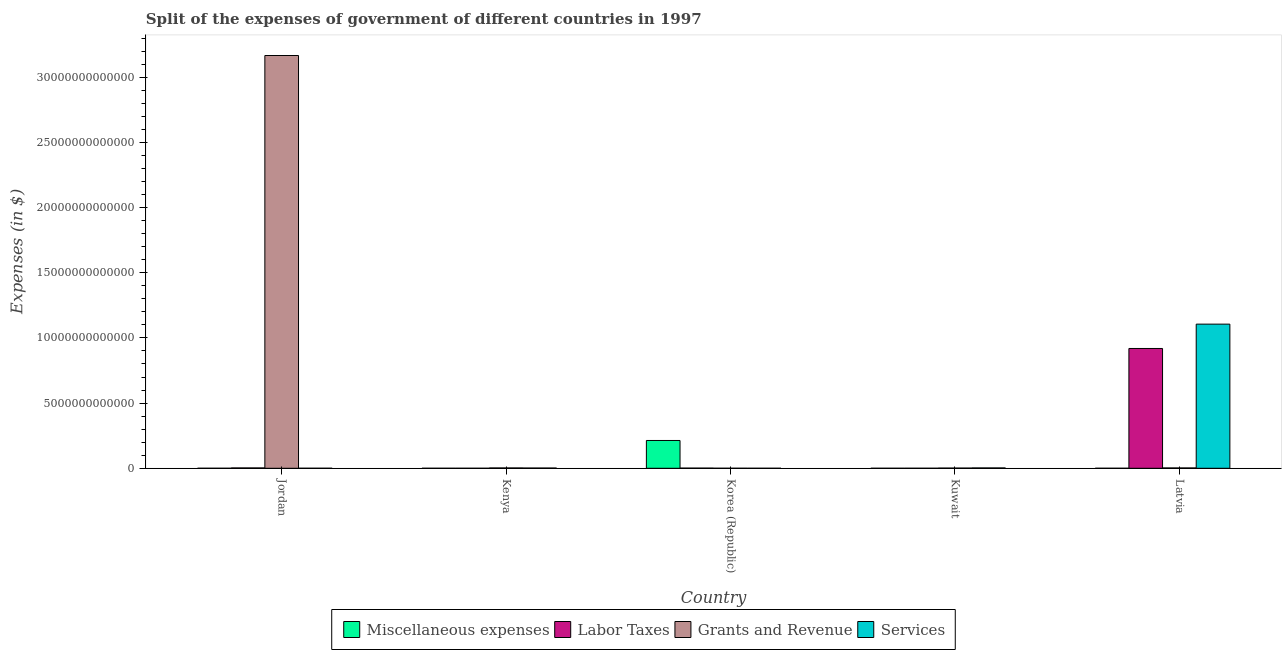How many different coloured bars are there?
Offer a very short reply. 4. How many groups of bars are there?
Your response must be concise. 5. Are the number of bars per tick equal to the number of legend labels?
Keep it short and to the point. Yes. Are the number of bars on each tick of the X-axis equal?
Your answer should be compact. Yes. What is the label of the 1st group of bars from the left?
Offer a terse response. Jordan. In how many cases, is the number of bars for a given country not equal to the number of legend labels?
Make the answer very short. 0. What is the amount spent on miscellaneous expenses in Kenya?
Offer a terse response. 2.31e+08. Across all countries, what is the maximum amount spent on miscellaneous expenses?
Keep it short and to the point. 2.13e+12. Across all countries, what is the minimum amount spent on miscellaneous expenses?
Provide a succinct answer. 2.09e+07. In which country was the amount spent on grants and revenue maximum?
Offer a very short reply. Jordan. In which country was the amount spent on labor taxes minimum?
Make the answer very short. Kenya. What is the total amount spent on grants and revenue in the graph?
Your answer should be compact. 3.17e+13. What is the difference between the amount spent on grants and revenue in Kenya and that in Korea (Republic)?
Your answer should be very brief. 2.38e+1. What is the difference between the amount spent on services in Jordan and the amount spent on miscellaneous expenses in Korea (Republic)?
Ensure brevity in your answer.  -2.13e+12. What is the average amount spent on services per country?
Provide a succinct answer. 2.22e+12. What is the difference between the amount spent on grants and revenue and amount spent on labor taxes in Korea (Republic)?
Provide a succinct answer. -1.10e+1. What is the ratio of the amount spent on miscellaneous expenses in Korea (Republic) to that in Kuwait?
Your response must be concise. 9647.06. Is the difference between the amount spent on labor taxes in Korea (Republic) and Kuwait greater than the difference between the amount spent on services in Korea (Republic) and Kuwait?
Provide a short and direct response. Yes. What is the difference between the highest and the second highest amount spent on labor taxes?
Make the answer very short. 9.16e+12. What is the difference between the highest and the lowest amount spent on services?
Ensure brevity in your answer.  1.11e+13. Is the sum of the amount spent on services in Jordan and Kenya greater than the maximum amount spent on grants and revenue across all countries?
Provide a succinct answer. No. What does the 1st bar from the left in Korea (Republic) represents?
Your answer should be compact. Miscellaneous expenses. What does the 3rd bar from the right in Kuwait represents?
Make the answer very short. Labor Taxes. Is it the case that in every country, the sum of the amount spent on miscellaneous expenses and amount spent on labor taxes is greater than the amount spent on grants and revenue?
Make the answer very short. No. How many bars are there?
Give a very brief answer. 20. Are all the bars in the graph horizontal?
Provide a short and direct response. No. How many countries are there in the graph?
Your answer should be compact. 5. What is the difference between two consecutive major ticks on the Y-axis?
Provide a short and direct response. 5.00e+12. Does the graph contain any zero values?
Your answer should be very brief. No. Does the graph contain grids?
Your answer should be compact. No. What is the title of the graph?
Your response must be concise. Split of the expenses of government of different countries in 1997. What is the label or title of the X-axis?
Give a very brief answer. Country. What is the label or title of the Y-axis?
Provide a succinct answer. Expenses (in $). What is the Expenses (in $) in Miscellaneous expenses in Jordan?
Your answer should be compact. 6.10e+07. What is the Expenses (in $) in Labor Taxes in Jordan?
Your answer should be compact. 2.58e+1. What is the Expenses (in $) in Grants and Revenue in Jordan?
Offer a terse response. 3.17e+13. What is the Expenses (in $) in Services in Jordan?
Give a very brief answer. 1.45e+09. What is the Expenses (in $) of Miscellaneous expenses in Kenya?
Offer a terse response. 2.31e+08. What is the Expenses (in $) in Labor Taxes in Kenya?
Ensure brevity in your answer.  1.24e+08. What is the Expenses (in $) of Grants and Revenue in Kenya?
Provide a short and direct response. 2.43e+1. What is the Expenses (in $) in Services in Kenya?
Ensure brevity in your answer.  1.71e+1. What is the Expenses (in $) of Miscellaneous expenses in Korea (Republic)?
Make the answer very short. 2.13e+12. What is the Expenses (in $) of Labor Taxes in Korea (Republic)?
Give a very brief answer. 1.15e+1. What is the Expenses (in $) of Grants and Revenue in Korea (Republic)?
Offer a very short reply. 5.38e+08. What is the Expenses (in $) of Services in Korea (Republic)?
Your answer should be very brief. 8.06e+07. What is the Expenses (in $) of Miscellaneous expenses in Kuwait?
Provide a short and direct response. 2.21e+08. What is the Expenses (in $) of Labor Taxes in Kuwait?
Make the answer very short. 1.22e+09. What is the Expenses (in $) of Grants and Revenue in Kuwait?
Your answer should be compact. 1.39e+1. What is the Expenses (in $) in Services in Kuwait?
Your answer should be very brief. 2.55e+1. What is the Expenses (in $) of Miscellaneous expenses in Latvia?
Your answer should be very brief. 2.09e+07. What is the Expenses (in $) in Labor Taxes in Latvia?
Offer a terse response. 9.19e+12. What is the Expenses (in $) of Grants and Revenue in Latvia?
Your answer should be very brief. 2.46e+1. What is the Expenses (in $) in Services in Latvia?
Your answer should be very brief. 1.11e+13. Across all countries, what is the maximum Expenses (in $) of Miscellaneous expenses?
Offer a very short reply. 2.13e+12. Across all countries, what is the maximum Expenses (in $) in Labor Taxes?
Your response must be concise. 9.19e+12. Across all countries, what is the maximum Expenses (in $) of Grants and Revenue?
Provide a succinct answer. 3.17e+13. Across all countries, what is the maximum Expenses (in $) in Services?
Your answer should be very brief. 1.11e+13. Across all countries, what is the minimum Expenses (in $) of Miscellaneous expenses?
Provide a short and direct response. 2.09e+07. Across all countries, what is the minimum Expenses (in $) of Labor Taxes?
Your response must be concise. 1.24e+08. Across all countries, what is the minimum Expenses (in $) in Grants and Revenue?
Your answer should be very brief. 5.38e+08. Across all countries, what is the minimum Expenses (in $) in Services?
Give a very brief answer. 8.06e+07. What is the total Expenses (in $) in Miscellaneous expenses in the graph?
Provide a succinct answer. 2.13e+12. What is the total Expenses (in $) in Labor Taxes in the graph?
Your response must be concise. 9.23e+12. What is the total Expenses (in $) of Grants and Revenue in the graph?
Offer a terse response. 3.17e+13. What is the total Expenses (in $) of Services in the graph?
Your answer should be very brief. 1.11e+13. What is the difference between the Expenses (in $) of Miscellaneous expenses in Jordan and that in Kenya?
Your answer should be compact. -1.70e+08. What is the difference between the Expenses (in $) of Labor Taxes in Jordan and that in Kenya?
Provide a short and direct response. 2.56e+1. What is the difference between the Expenses (in $) of Grants and Revenue in Jordan and that in Kenya?
Ensure brevity in your answer.  3.16e+13. What is the difference between the Expenses (in $) of Services in Jordan and that in Kenya?
Your response must be concise. -1.56e+1. What is the difference between the Expenses (in $) of Miscellaneous expenses in Jordan and that in Korea (Republic)?
Your response must be concise. -2.13e+12. What is the difference between the Expenses (in $) in Labor Taxes in Jordan and that in Korea (Republic)?
Your answer should be very brief. 1.42e+1. What is the difference between the Expenses (in $) of Grants and Revenue in Jordan and that in Korea (Republic)?
Your answer should be compact. 3.17e+13. What is the difference between the Expenses (in $) in Services in Jordan and that in Korea (Republic)?
Offer a very short reply. 1.37e+09. What is the difference between the Expenses (in $) of Miscellaneous expenses in Jordan and that in Kuwait?
Ensure brevity in your answer.  -1.60e+08. What is the difference between the Expenses (in $) in Labor Taxes in Jordan and that in Kuwait?
Provide a short and direct response. 2.45e+1. What is the difference between the Expenses (in $) in Grants and Revenue in Jordan and that in Kuwait?
Give a very brief answer. 3.16e+13. What is the difference between the Expenses (in $) in Services in Jordan and that in Kuwait?
Offer a very short reply. -2.41e+1. What is the difference between the Expenses (in $) of Miscellaneous expenses in Jordan and that in Latvia?
Your response must be concise. 4.01e+07. What is the difference between the Expenses (in $) of Labor Taxes in Jordan and that in Latvia?
Provide a succinct answer. -9.16e+12. What is the difference between the Expenses (in $) in Grants and Revenue in Jordan and that in Latvia?
Keep it short and to the point. 3.16e+13. What is the difference between the Expenses (in $) in Services in Jordan and that in Latvia?
Your answer should be compact. -1.11e+13. What is the difference between the Expenses (in $) of Miscellaneous expenses in Kenya and that in Korea (Republic)?
Make the answer very short. -2.13e+12. What is the difference between the Expenses (in $) in Labor Taxes in Kenya and that in Korea (Republic)?
Give a very brief answer. -1.14e+1. What is the difference between the Expenses (in $) of Grants and Revenue in Kenya and that in Korea (Republic)?
Provide a succinct answer. 2.38e+1. What is the difference between the Expenses (in $) in Services in Kenya and that in Korea (Republic)?
Your answer should be very brief. 1.70e+1. What is the difference between the Expenses (in $) in Labor Taxes in Kenya and that in Kuwait?
Offer a very short reply. -1.09e+09. What is the difference between the Expenses (in $) in Grants and Revenue in Kenya and that in Kuwait?
Make the answer very short. 1.04e+1. What is the difference between the Expenses (in $) of Services in Kenya and that in Kuwait?
Make the answer very short. -8.45e+09. What is the difference between the Expenses (in $) of Miscellaneous expenses in Kenya and that in Latvia?
Offer a terse response. 2.10e+08. What is the difference between the Expenses (in $) of Labor Taxes in Kenya and that in Latvia?
Offer a terse response. -9.19e+12. What is the difference between the Expenses (in $) in Grants and Revenue in Kenya and that in Latvia?
Give a very brief answer. -3.43e+08. What is the difference between the Expenses (in $) in Services in Kenya and that in Latvia?
Give a very brief answer. -1.10e+13. What is the difference between the Expenses (in $) of Miscellaneous expenses in Korea (Republic) and that in Kuwait?
Provide a succinct answer. 2.13e+12. What is the difference between the Expenses (in $) of Labor Taxes in Korea (Republic) and that in Kuwait?
Your answer should be very brief. 1.03e+1. What is the difference between the Expenses (in $) in Grants and Revenue in Korea (Republic) and that in Kuwait?
Ensure brevity in your answer.  -1.34e+1. What is the difference between the Expenses (in $) in Services in Korea (Republic) and that in Kuwait?
Offer a terse response. -2.55e+1. What is the difference between the Expenses (in $) in Miscellaneous expenses in Korea (Republic) and that in Latvia?
Provide a short and direct response. 2.13e+12. What is the difference between the Expenses (in $) of Labor Taxes in Korea (Republic) and that in Latvia?
Provide a succinct answer. -9.18e+12. What is the difference between the Expenses (in $) in Grants and Revenue in Korea (Republic) and that in Latvia?
Provide a succinct answer. -2.41e+1. What is the difference between the Expenses (in $) of Services in Korea (Republic) and that in Latvia?
Your response must be concise. -1.11e+13. What is the difference between the Expenses (in $) of Miscellaneous expenses in Kuwait and that in Latvia?
Provide a succinct answer. 2.00e+08. What is the difference between the Expenses (in $) of Labor Taxes in Kuwait and that in Latvia?
Your answer should be compact. -9.19e+12. What is the difference between the Expenses (in $) of Grants and Revenue in Kuwait and that in Latvia?
Provide a succinct answer. -1.07e+1. What is the difference between the Expenses (in $) in Services in Kuwait and that in Latvia?
Your response must be concise. -1.10e+13. What is the difference between the Expenses (in $) in Miscellaneous expenses in Jordan and the Expenses (in $) in Labor Taxes in Kenya?
Your response must be concise. -6.30e+07. What is the difference between the Expenses (in $) of Miscellaneous expenses in Jordan and the Expenses (in $) of Grants and Revenue in Kenya?
Your answer should be compact. -2.42e+1. What is the difference between the Expenses (in $) of Miscellaneous expenses in Jordan and the Expenses (in $) of Services in Kenya?
Your answer should be compact. -1.70e+1. What is the difference between the Expenses (in $) of Labor Taxes in Jordan and the Expenses (in $) of Grants and Revenue in Kenya?
Keep it short and to the point. 1.46e+09. What is the difference between the Expenses (in $) of Labor Taxes in Jordan and the Expenses (in $) of Services in Kenya?
Provide a short and direct response. 8.66e+09. What is the difference between the Expenses (in $) in Grants and Revenue in Jordan and the Expenses (in $) in Services in Kenya?
Give a very brief answer. 3.16e+13. What is the difference between the Expenses (in $) in Miscellaneous expenses in Jordan and the Expenses (in $) in Labor Taxes in Korea (Republic)?
Ensure brevity in your answer.  -1.15e+1. What is the difference between the Expenses (in $) of Miscellaneous expenses in Jordan and the Expenses (in $) of Grants and Revenue in Korea (Republic)?
Offer a terse response. -4.77e+08. What is the difference between the Expenses (in $) in Miscellaneous expenses in Jordan and the Expenses (in $) in Services in Korea (Republic)?
Offer a terse response. -1.97e+07. What is the difference between the Expenses (in $) in Labor Taxes in Jordan and the Expenses (in $) in Grants and Revenue in Korea (Republic)?
Provide a succinct answer. 2.52e+1. What is the difference between the Expenses (in $) in Labor Taxes in Jordan and the Expenses (in $) in Services in Korea (Republic)?
Make the answer very short. 2.57e+1. What is the difference between the Expenses (in $) in Grants and Revenue in Jordan and the Expenses (in $) in Services in Korea (Republic)?
Your response must be concise. 3.17e+13. What is the difference between the Expenses (in $) in Miscellaneous expenses in Jordan and the Expenses (in $) in Labor Taxes in Kuwait?
Your response must be concise. -1.15e+09. What is the difference between the Expenses (in $) of Miscellaneous expenses in Jordan and the Expenses (in $) of Grants and Revenue in Kuwait?
Your answer should be compact. -1.38e+1. What is the difference between the Expenses (in $) in Miscellaneous expenses in Jordan and the Expenses (in $) in Services in Kuwait?
Provide a short and direct response. -2.55e+1. What is the difference between the Expenses (in $) in Labor Taxes in Jordan and the Expenses (in $) in Grants and Revenue in Kuwait?
Keep it short and to the point. 1.18e+1. What is the difference between the Expenses (in $) of Labor Taxes in Jordan and the Expenses (in $) of Services in Kuwait?
Your answer should be compact. 2.15e+08. What is the difference between the Expenses (in $) in Grants and Revenue in Jordan and the Expenses (in $) in Services in Kuwait?
Offer a terse response. 3.16e+13. What is the difference between the Expenses (in $) in Miscellaneous expenses in Jordan and the Expenses (in $) in Labor Taxes in Latvia?
Ensure brevity in your answer.  -9.19e+12. What is the difference between the Expenses (in $) in Miscellaneous expenses in Jordan and the Expenses (in $) in Grants and Revenue in Latvia?
Provide a succinct answer. -2.46e+1. What is the difference between the Expenses (in $) in Miscellaneous expenses in Jordan and the Expenses (in $) in Services in Latvia?
Your answer should be very brief. -1.11e+13. What is the difference between the Expenses (in $) of Labor Taxes in Jordan and the Expenses (in $) of Grants and Revenue in Latvia?
Make the answer very short. 1.12e+09. What is the difference between the Expenses (in $) of Labor Taxes in Jordan and the Expenses (in $) of Services in Latvia?
Keep it short and to the point. -1.10e+13. What is the difference between the Expenses (in $) of Grants and Revenue in Jordan and the Expenses (in $) of Services in Latvia?
Your answer should be compact. 2.06e+13. What is the difference between the Expenses (in $) of Miscellaneous expenses in Kenya and the Expenses (in $) of Labor Taxes in Korea (Republic)?
Ensure brevity in your answer.  -1.13e+1. What is the difference between the Expenses (in $) of Miscellaneous expenses in Kenya and the Expenses (in $) of Grants and Revenue in Korea (Republic)?
Give a very brief answer. -3.07e+08. What is the difference between the Expenses (in $) of Miscellaneous expenses in Kenya and the Expenses (in $) of Services in Korea (Republic)?
Offer a terse response. 1.50e+08. What is the difference between the Expenses (in $) of Labor Taxes in Kenya and the Expenses (in $) of Grants and Revenue in Korea (Republic)?
Your answer should be compact. -4.14e+08. What is the difference between the Expenses (in $) in Labor Taxes in Kenya and the Expenses (in $) in Services in Korea (Republic)?
Provide a short and direct response. 4.34e+07. What is the difference between the Expenses (in $) in Grants and Revenue in Kenya and the Expenses (in $) in Services in Korea (Republic)?
Keep it short and to the point. 2.42e+1. What is the difference between the Expenses (in $) in Miscellaneous expenses in Kenya and the Expenses (in $) in Labor Taxes in Kuwait?
Ensure brevity in your answer.  -9.84e+08. What is the difference between the Expenses (in $) in Miscellaneous expenses in Kenya and the Expenses (in $) in Grants and Revenue in Kuwait?
Your answer should be compact. -1.37e+1. What is the difference between the Expenses (in $) of Miscellaneous expenses in Kenya and the Expenses (in $) of Services in Kuwait?
Provide a succinct answer. -2.53e+1. What is the difference between the Expenses (in $) of Labor Taxes in Kenya and the Expenses (in $) of Grants and Revenue in Kuwait?
Offer a very short reply. -1.38e+1. What is the difference between the Expenses (in $) of Labor Taxes in Kenya and the Expenses (in $) of Services in Kuwait?
Offer a terse response. -2.54e+1. What is the difference between the Expenses (in $) in Grants and Revenue in Kenya and the Expenses (in $) in Services in Kuwait?
Your answer should be very brief. -1.24e+09. What is the difference between the Expenses (in $) in Miscellaneous expenses in Kenya and the Expenses (in $) in Labor Taxes in Latvia?
Ensure brevity in your answer.  -9.19e+12. What is the difference between the Expenses (in $) of Miscellaneous expenses in Kenya and the Expenses (in $) of Grants and Revenue in Latvia?
Provide a short and direct response. -2.44e+1. What is the difference between the Expenses (in $) in Miscellaneous expenses in Kenya and the Expenses (in $) in Services in Latvia?
Ensure brevity in your answer.  -1.11e+13. What is the difference between the Expenses (in $) of Labor Taxes in Kenya and the Expenses (in $) of Grants and Revenue in Latvia?
Provide a succinct answer. -2.45e+1. What is the difference between the Expenses (in $) of Labor Taxes in Kenya and the Expenses (in $) of Services in Latvia?
Your answer should be compact. -1.11e+13. What is the difference between the Expenses (in $) of Grants and Revenue in Kenya and the Expenses (in $) of Services in Latvia?
Offer a terse response. -1.10e+13. What is the difference between the Expenses (in $) of Miscellaneous expenses in Korea (Republic) and the Expenses (in $) of Labor Taxes in Kuwait?
Give a very brief answer. 2.13e+12. What is the difference between the Expenses (in $) in Miscellaneous expenses in Korea (Republic) and the Expenses (in $) in Grants and Revenue in Kuwait?
Ensure brevity in your answer.  2.12e+12. What is the difference between the Expenses (in $) in Miscellaneous expenses in Korea (Republic) and the Expenses (in $) in Services in Kuwait?
Offer a terse response. 2.11e+12. What is the difference between the Expenses (in $) of Labor Taxes in Korea (Republic) and the Expenses (in $) of Grants and Revenue in Kuwait?
Offer a very short reply. -2.37e+09. What is the difference between the Expenses (in $) in Labor Taxes in Korea (Republic) and the Expenses (in $) in Services in Kuwait?
Your answer should be very brief. -1.40e+1. What is the difference between the Expenses (in $) of Grants and Revenue in Korea (Republic) and the Expenses (in $) of Services in Kuwait?
Give a very brief answer. -2.50e+1. What is the difference between the Expenses (in $) of Miscellaneous expenses in Korea (Republic) and the Expenses (in $) of Labor Taxes in Latvia?
Your response must be concise. -7.06e+12. What is the difference between the Expenses (in $) of Miscellaneous expenses in Korea (Republic) and the Expenses (in $) of Grants and Revenue in Latvia?
Provide a short and direct response. 2.11e+12. What is the difference between the Expenses (in $) in Miscellaneous expenses in Korea (Republic) and the Expenses (in $) in Services in Latvia?
Provide a succinct answer. -8.92e+12. What is the difference between the Expenses (in $) of Labor Taxes in Korea (Republic) and the Expenses (in $) of Grants and Revenue in Latvia?
Give a very brief answer. -1.31e+1. What is the difference between the Expenses (in $) of Labor Taxes in Korea (Republic) and the Expenses (in $) of Services in Latvia?
Give a very brief answer. -1.10e+13. What is the difference between the Expenses (in $) in Grants and Revenue in Korea (Republic) and the Expenses (in $) in Services in Latvia?
Give a very brief answer. -1.11e+13. What is the difference between the Expenses (in $) in Miscellaneous expenses in Kuwait and the Expenses (in $) in Labor Taxes in Latvia?
Provide a succinct answer. -9.19e+12. What is the difference between the Expenses (in $) in Miscellaneous expenses in Kuwait and the Expenses (in $) in Grants and Revenue in Latvia?
Provide a short and direct response. -2.44e+1. What is the difference between the Expenses (in $) of Miscellaneous expenses in Kuwait and the Expenses (in $) of Services in Latvia?
Your response must be concise. -1.11e+13. What is the difference between the Expenses (in $) of Labor Taxes in Kuwait and the Expenses (in $) of Grants and Revenue in Latvia?
Your answer should be compact. -2.34e+1. What is the difference between the Expenses (in $) in Labor Taxes in Kuwait and the Expenses (in $) in Services in Latvia?
Ensure brevity in your answer.  -1.11e+13. What is the difference between the Expenses (in $) in Grants and Revenue in Kuwait and the Expenses (in $) in Services in Latvia?
Provide a succinct answer. -1.10e+13. What is the average Expenses (in $) of Miscellaneous expenses per country?
Offer a very short reply. 4.27e+11. What is the average Expenses (in $) in Labor Taxes per country?
Ensure brevity in your answer.  1.85e+12. What is the average Expenses (in $) of Grants and Revenue per country?
Give a very brief answer. 6.34e+12. What is the average Expenses (in $) of Services per country?
Your response must be concise. 2.22e+12. What is the difference between the Expenses (in $) of Miscellaneous expenses and Expenses (in $) of Labor Taxes in Jordan?
Provide a short and direct response. -2.57e+1. What is the difference between the Expenses (in $) of Miscellaneous expenses and Expenses (in $) of Grants and Revenue in Jordan?
Your response must be concise. -3.17e+13. What is the difference between the Expenses (in $) of Miscellaneous expenses and Expenses (in $) of Services in Jordan?
Offer a terse response. -1.39e+09. What is the difference between the Expenses (in $) in Labor Taxes and Expenses (in $) in Grants and Revenue in Jordan?
Make the answer very short. -3.16e+13. What is the difference between the Expenses (in $) of Labor Taxes and Expenses (in $) of Services in Jordan?
Your answer should be very brief. 2.43e+1. What is the difference between the Expenses (in $) in Grants and Revenue and Expenses (in $) in Services in Jordan?
Give a very brief answer. 3.17e+13. What is the difference between the Expenses (in $) in Miscellaneous expenses and Expenses (in $) in Labor Taxes in Kenya?
Your answer should be very brief. 1.07e+08. What is the difference between the Expenses (in $) in Miscellaneous expenses and Expenses (in $) in Grants and Revenue in Kenya?
Your answer should be very brief. -2.41e+1. What is the difference between the Expenses (in $) in Miscellaneous expenses and Expenses (in $) in Services in Kenya?
Make the answer very short. -1.69e+1. What is the difference between the Expenses (in $) in Labor Taxes and Expenses (in $) in Grants and Revenue in Kenya?
Your answer should be compact. -2.42e+1. What is the difference between the Expenses (in $) in Labor Taxes and Expenses (in $) in Services in Kenya?
Your response must be concise. -1.70e+1. What is the difference between the Expenses (in $) in Grants and Revenue and Expenses (in $) in Services in Kenya?
Your answer should be very brief. 7.20e+09. What is the difference between the Expenses (in $) of Miscellaneous expenses and Expenses (in $) of Labor Taxes in Korea (Republic)?
Provide a succinct answer. 2.12e+12. What is the difference between the Expenses (in $) of Miscellaneous expenses and Expenses (in $) of Grants and Revenue in Korea (Republic)?
Your answer should be very brief. 2.13e+12. What is the difference between the Expenses (in $) of Miscellaneous expenses and Expenses (in $) of Services in Korea (Republic)?
Offer a very short reply. 2.13e+12. What is the difference between the Expenses (in $) in Labor Taxes and Expenses (in $) in Grants and Revenue in Korea (Republic)?
Ensure brevity in your answer.  1.10e+1. What is the difference between the Expenses (in $) of Labor Taxes and Expenses (in $) of Services in Korea (Republic)?
Give a very brief answer. 1.15e+1. What is the difference between the Expenses (in $) of Grants and Revenue and Expenses (in $) of Services in Korea (Republic)?
Your answer should be very brief. 4.57e+08. What is the difference between the Expenses (in $) of Miscellaneous expenses and Expenses (in $) of Labor Taxes in Kuwait?
Ensure brevity in your answer.  -9.94e+08. What is the difference between the Expenses (in $) of Miscellaneous expenses and Expenses (in $) of Grants and Revenue in Kuwait?
Offer a very short reply. -1.37e+1. What is the difference between the Expenses (in $) in Miscellaneous expenses and Expenses (in $) in Services in Kuwait?
Provide a short and direct response. -2.53e+1. What is the difference between the Expenses (in $) in Labor Taxes and Expenses (in $) in Grants and Revenue in Kuwait?
Provide a short and direct response. -1.27e+1. What is the difference between the Expenses (in $) in Labor Taxes and Expenses (in $) in Services in Kuwait?
Make the answer very short. -2.43e+1. What is the difference between the Expenses (in $) in Grants and Revenue and Expenses (in $) in Services in Kuwait?
Provide a succinct answer. -1.16e+1. What is the difference between the Expenses (in $) of Miscellaneous expenses and Expenses (in $) of Labor Taxes in Latvia?
Provide a short and direct response. -9.19e+12. What is the difference between the Expenses (in $) of Miscellaneous expenses and Expenses (in $) of Grants and Revenue in Latvia?
Provide a succinct answer. -2.46e+1. What is the difference between the Expenses (in $) of Miscellaneous expenses and Expenses (in $) of Services in Latvia?
Offer a terse response. -1.11e+13. What is the difference between the Expenses (in $) in Labor Taxes and Expenses (in $) in Grants and Revenue in Latvia?
Your answer should be compact. 9.16e+12. What is the difference between the Expenses (in $) in Labor Taxes and Expenses (in $) in Services in Latvia?
Your response must be concise. -1.87e+12. What is the difference between the Expenses (in $) of Grants and Revenue and Expenses (in $) of Services in Latvia?
Provide a succinct answer. -1.10e+13. What is the ratio of the Expenses (in $) in Miscellaneous expenses in Jordan to that in Kenya?
Your answer should be compact. 0.26. What is the ratio of the Expenses (in $) of Labor Taxes in Jordan to that in Kenya?
Your answer should be compact. 207.75. What is the ratio of the Expenses (in $) of Grants and Revenue in Jordan to that in Kenya?
Your response must be concise. 1303.04. What is the ratio of the Expenses (in $) in Services in Jordan to that in Kenya?
Provide a short and direct response. 0.08. What is the ratio of the Expenses (in $) of Labor Taxes in Jordan to that in Korea (Republic)?
Make the answer very short. 2.23. What is the ratio of the Expenses (in $) of Grants and Revenue in Jordan to that in Korea (Republic)?
Offer a very short reply. 5.89e+04. What is the ratio of the Expenses (in $) of Services in Jordan to that in Korea (Republic)?
Give a very brief answer. 17.95. What is the ratio of the Expenses (in $) in Miscellaneous expenses in Jordan to that in Kuwait?
Provide a short and direct response. 0.28. What is the ratio of the Expenses (in $) in Labor Taxes in Jordan to that in Kuwait?
Offer a very short reply. 21.2. What is the ratio of the Expenses (in $) of Grants and Revenue in Jordan to that in Kuwait?
Your answer should be very brief. 2276.55. What is the ratio of the Expenses (in $) of Services in Jordan to that in Kuwait?
Your answer should be compact. 0.06. What is the ratio of the Expenses (in $) in Miscellaneous expenses in Jordan to that in Latvia?
Provide a succinct answer. 2.92. What is the ratio of the Expenses (in $) of Labor Taxes in Jordan to that in Latvia?
Ensure brevity in your answer.  0. What is the ratio of the Expenses (in $) in Grants and Revenue in Jordan to that in Latvia?
Ensure brevity in your answer.  1284.9. What is the ratio of the Expenses (in $) of Services in Jordan to that in Latvia?
Your answer should be very brief. 0. What is the ratio of the Expenses (in $) of Miscellaneous expenses in Kenya to that in Korea (Republic)?
Your answer should be compact. 0. What is the ratio of the Expenses (in $) in Labor Taxes in Kenya to that in Korea (Republic)?
Your answer should be compact. 0.01. What is the ratio of the Expenses (in $) of Grants and Revenue in Kenya to that in Korea (Republic)?
Provide a succinct answer. 45.18. What is the ratio of the Expenses (in $) in Services in Kenya to that in Korea (Republic)?
Your response must be concise. 212.04. What is the ratio of the Expenses (in $) of Miscellaneous expenses in Kenya to that in Kuwait?
Offer a very short reply. 1.05. What is the ratio of the Expenses (in $) in Labor Taxes in Kenya to that in Kuwait?
Offer a terse response. 0.1. What is the ratio of the Expenses (in $) of Grants and Revenue in Kenya to that in Kuwait?
Keep it short and to the point. 1.75. What is the ratio of the Expenses (in $) in Services in Kenya to that in Kuwait?
Provide a short and direct response. 0.67. What is the ratio of the Expenses (in $) of Miscellaneous expenses in Kenya to that in Latvia?
Give a very brief answer. 11.06. What is the ratio of the Expenses (in $) of Labor Taxes in Kenya to that in Latvia?
Offer a terse response. 0. What is the ratio of the Expenses (in $) of Grants and Revenue in Kenya to that in Latvia?
Ensure brevity in your answer.  0.99. What is the ratio of the Expenses (in $) in Services in Kenya to that in Latvia?
Offer a terse response. 0. What is the ratio of the Expenses (in $) of Miscellaneous expenses in Korea (Republic) to that in Kuwait?
Your response must be concise. 9647.06. What is the ratio of the Expenses (in $) of Labor Taxes in Korea (Republic) to that in Kuwait?
Offer a very short reply. 9.5. What is the ratio of the Expenses (in $) in Grants and Revenue in Korea (Republic) to that in Kuwait?
Offer a very short reply. 0.04. What is the ratio of the Expenses (in $) of Services in Korea (Republic) to that in Kuwait?
Offer a terse response. 0. What is the ratio of the Expenses (in $) in Miscellaneous expenses in Korea (Republic) to that in Latvia?
Provide a succinct answer. 1.02e+05. What is the ratio of the Expenses (in $) in Labor Taxes in Korea (Republic) to that in Latvia?
Your answer should be very brief. 0. What is the ratio of the Expenses (in $) of Grants and Revenue in Korea (Republic) to that in Latvia?
Provide a short and direct response. 0.02. What is the ratio of the Expenses (in $) in Miscellaneous expenses in Kuwait to that in Latvia?
Your answer should be very brief. 10.58. What is the ratio of the Expenses (in $) of Grants and Revenue in Kuwait to that in Latvia?
Ensure brevity in your answer.  0.56. What is the ratio of the Expenses (in $) of Services in Kuwait to that in Latvia?
Offer a very short reply. 0. What is the difference between the highest and the second highest Expenses (in $) of Miscellaneous expenses?
Keep it short and to the point. 2.13e+12. What is the difference between the highest and the second highest Expenses (in $) in Labor Taxes?
Your response must be concise. 9.16e+12. What is the difference between the highest and the second highest Expenses (in $) of Grants and Revenue?
Ensure brevity in your answer.  3.16e+13. What is the difference between the highest and the second highest Expenses (in $) in Services?
Ensure brevity in your answer.  1.10e+13. What is the difference between the highest and the lowest Expenses (in $) in Miscellaneous expenses?
Offer a terse response. 2.13e+12. What is the difference between the highest and the lowest Expenses (in $) of Labor Taxes?
Give a very brief answer. 9.19e+12. What is the difference between the highest and the lowest Expenses (in $) in Grants and Revenue?
Your answer should be compact. 3.17e+13. What is the difference between the highest and the lowest Expenses (in $) in Services?
Offer a very short reply. 1.11e+13. 